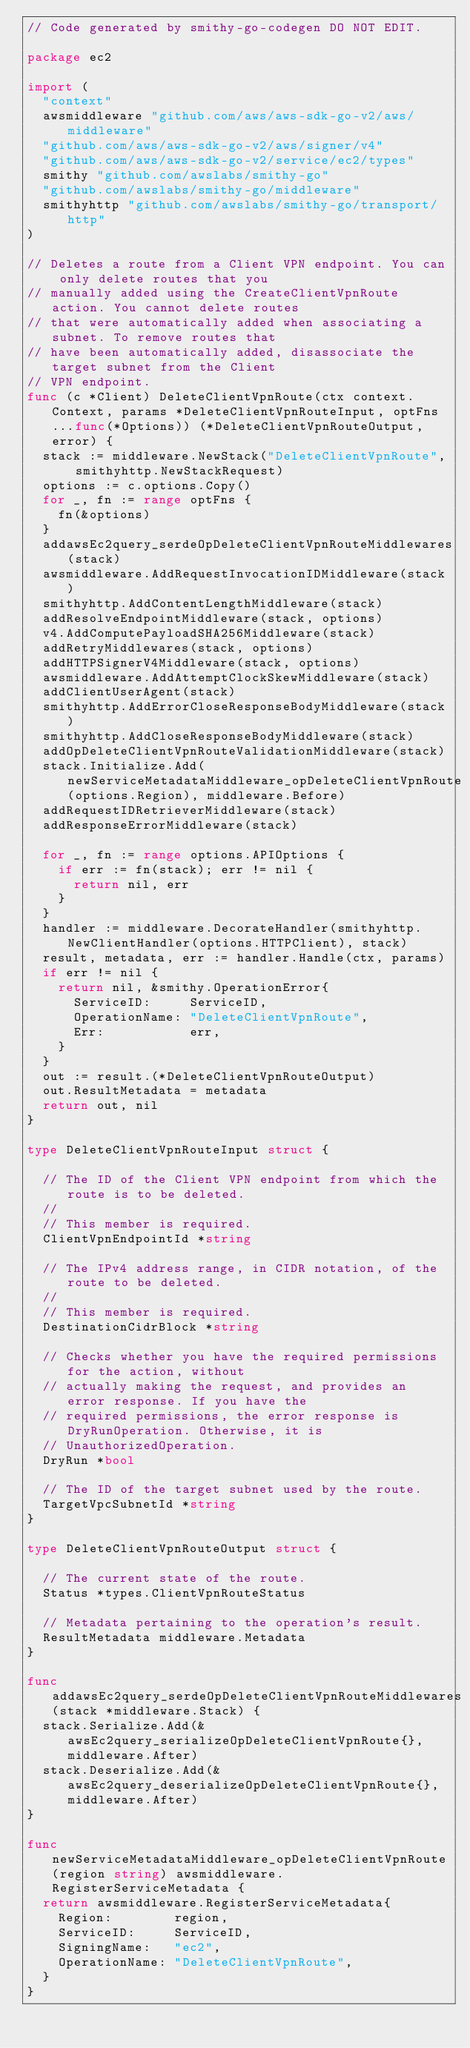Convert code to text. <code><loc_0><loc_0><loc_500><loc_500><_Go_>// Code generated by smithy-go-codegen DO NOT EDIT.

package ec2

import (
	"context"
	awsmiddleware "github.com/aws/aws-sdk-go-v2/aws/middleware"
	"github.com/aws/aws-sdk-go-v2/aws/signer/v4"
	"github.com/aws/aws-sdk-go-v2/service/ec2/types"
	smithy "github.com/awslabs/smithy-go"
	"github.com/awslabs/smithy-go/middleware"
	smithyhttp "github.com/awslabs/smithy-go/transport/http"
)

// Deletes a route from a Client VPN endpoint. You can only delete routes that you
// manually added using the CreateClientVpnRoute action. You cannot delete routes
// that were automatically added when associating a subnet. To remove routes that
// have been automatically added, disassociate the target subnet from the Client
// VPN endpoint.
func (c *Client) DeleteClientVpnRoute(ctx context.Context, params *DeleteClientVpnRouteInput, optFns ...func(*Options)) (*DeleteClientVpnRouteOutput, error) {
	stack := middleware.NewStack("DeleteClientVpnRoute", smithyhttp.NewStackRequest)
	options := c.options.Copy()
	for _, fn := range optFns {
		fn(&options)
	}
	addawsEc2query_serdeOpDeleteClientVpnRouteMiddlewares(stack)
	awsmiddleware.AddRequestInvocationIDMiddleware(stack)
	smithyhttp.AddContentLengthMiddleware(stack)
	addResolveEndpointMiddleware(stack, options)
	v4.AddComputePayloadSHA256Middleware(stack)
	addRetryMiddlewares(stack, options)
	addHTTPSignerV4Middleware(stack, options)
	awsmiddleware.AddAttemptClockSkewMiddleware(stack)
	addClientUserAgent(stack)
	smithyhttp.AddErrorCloseResponseBodyMiddleware(stack)
	smithyhttp.AddCloseResponseBodyMiddleware(stack)
	addOpDeleteClientVpnRouteValidationMiddleware(stack)
	stack.Initialize.Add(newServiceMetadataMiddleware_opDeleteClientVpnRoute(options.Region), middleware.Before)
	addRequestIDRetrieverMiddleware(stack)
	addResponseErrorMiddleware(stack)

	for _, fn := range options.APIOptions {
		if err := fn(stack); err != nil {
			return nil, err
		}
	}
	handler := middleware.DecorateHandler(smithyhttp.NewClientHandler(options.HTTPClient), stack)
	result, metadata, err := handler.Handle(ctx, params)
	if err != nil {
		return nil, &smithy.OperationError{
			ServiceID:     ServiceID,
			OperationName: "DeleteClientVpnRoute",
			Err:           err,
		}
	}
	out := result.(*DeleteClientVpnRouteOutput)
	out.ResultMetadata = metadata
	return out, nil
}

type DeleteClientVpnRouteInput struct {

	// The ID of the Client VPN endpoint from which the route is to be deleted.
	//
	// This member is required.
	ClientVpnEndpointId *string

	// The IPv4 address range, in CIDR notation, of the route to be deleted.
	//
	// This member is required.
	DestinationCidrBlock *string

	// Checks whether you have the required permissions for the action, without
	// actually making the request, and provides an error response. If you have the
	// required permissions, the error response is DryRunOperation. Otherwise, it is
	// UnauthorizedOperation.
	DryRun *bool

	// The ID of the target subnet used by the route.
	TargetVpcSubnetId *string
}

type DeleteClientVpnRouteOutput struct {

	// The current state of the route.
	Status *types.ClientVpnRouteStatus

	// Metadata pertaining to the operation's result.
	ResultMetadata middleware.Metadata
}

func addawsEc2query_serdeOpDeleteClientVpnRouteMiddlewares(stack *middleware.Stack) {
	stack.Serialize.Add(&awsEc2query_serializeOpDeleteClientVpnRoute{}, middleware.After)
	stack.Deserialize.Add(&awsEc2query_deserializeOpDeleteClientVpnRoute{}, middleware.After)
}

func newServiceMetadataMiddleware_opDeleteClientVpnRoute(region string) awsmiddleware.RegisterServiceMetadata {
	return awsmiddleware.RegisterServiceMetadata{
		Region:        region,
		ServiceID:     ServiceID,
		SigningName:   "ec2",
		OperationName: "DeleteClientVpnRoute",
	}
}
</code> 